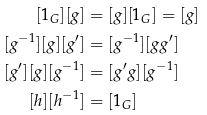Convert formula to latex. <formula><loc_0><loc_0><loc_500><loc_500>[ 1 _ { G } ] [ g ] & = [ g ] [ 1 _ { G } ] = [ g ] \\ [ g ^ { - 1 } ] [ g ] [ g ^ { \prime } ] & = [ g ^ { - 1 } ] [ g g ^ { \prime } ] \\ [ g ^ { \prime } ] [ g ] [ g ^ { - 1 } ] & = [ g ^ { \prime } g ] [ g ^ { - 1 } ] \\ [ h ] [ h ^ { - 1 } ] & = [ 1 _ { G } ]</formula> 